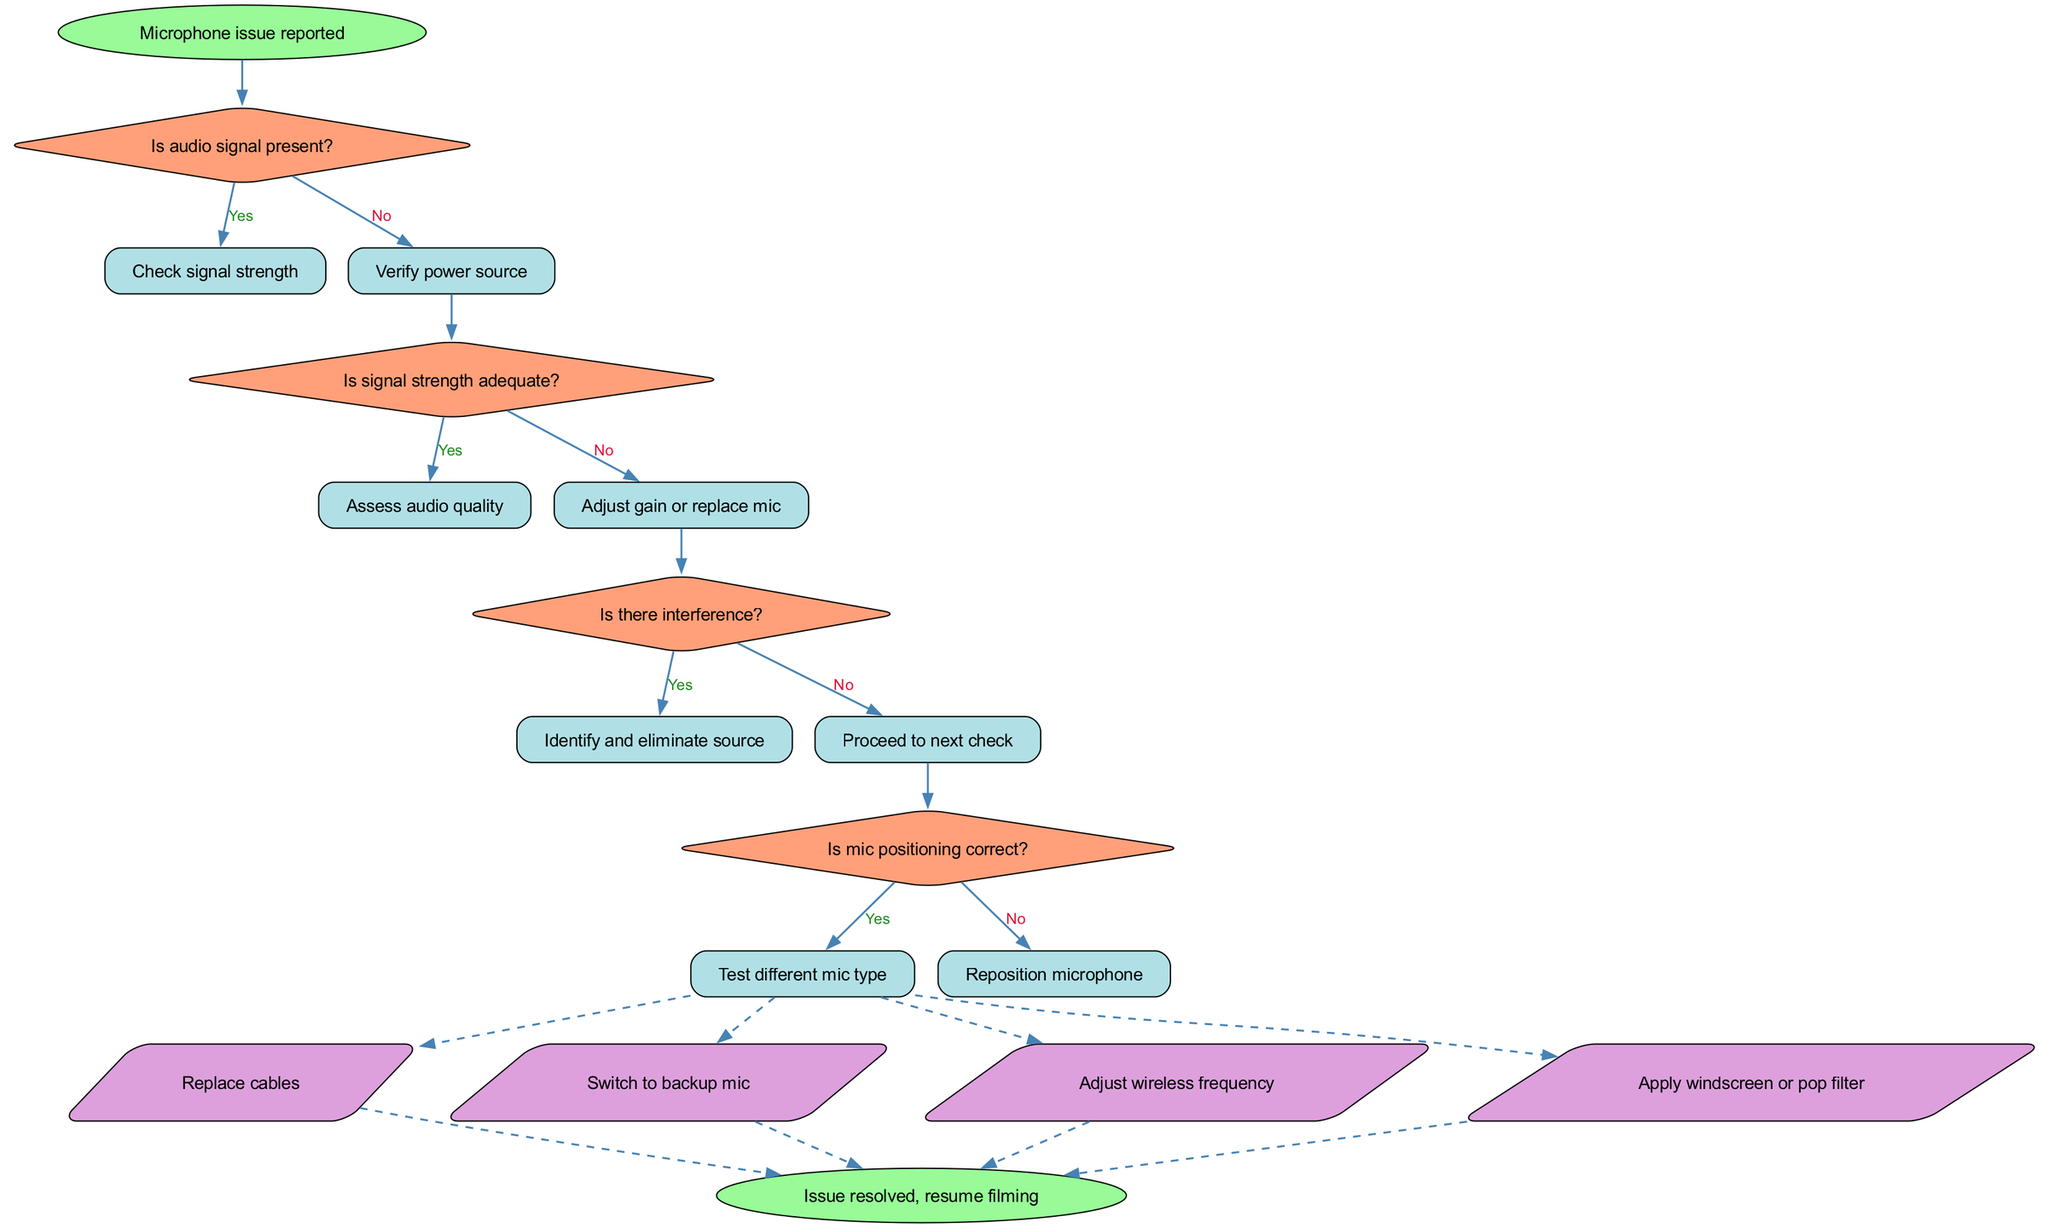What is the first step in the troubleshooting workflow? The diagram starts with the node named "Microphone issue reported," indicating that this is the first action in the workflow.
Answer: Microphone issue reported How many decision nodes are present in the diagram? The diagram contains four decision nodes, which ask about audio signal presence, signal strength, interference, and mic positioning.
Answer: 4 What follows after determining there is no audio signal? If there's no audio signal, the next step is to "Verify power source," as indicated by the directed edge from the corresponding decision node.
Answer: Verify power source If the signal strength is adequate, what action must be taken next? Once it is established that the signal strength is adequate, the next step is to "Assess audio quality," as indicated by the directed edge leading from that decision outcome.
Answer: Assess audio quality Which action is taken if there is interference? If there is interference, the workflow directs you to "Identify and eliminate source," based on the outcome of the related decision node concerning interference.
Answer: Identify and eliminate source What type of node is used to represent actions in the diagram? Actions in the diagram are represented by parallelogram-shaped nodes, as specified in the code for the visual representation.
Answer: Parallelogram Which decision leads to adjusting gain or replacing the microphone? The decision regarding "Is signal strength adequate?" with a "No" outcome leads to the action of "Adjust gain or replace mic," as described in the diagram's flow.
Answer: Adjust gain or replace mic How many actions can be taken after a positive assessment of mic positioning? After confirming mic positioning is correct, there are four actions available, as indicated by the dashed lines leading to the action nodes.
Answer: 4 What is required once the issue is resolved? Once the issue is resolved, the workflow concludes with the instruction to "resume filming," indicating the end phase of the troubleshooting process.
Answer: Resume filming 